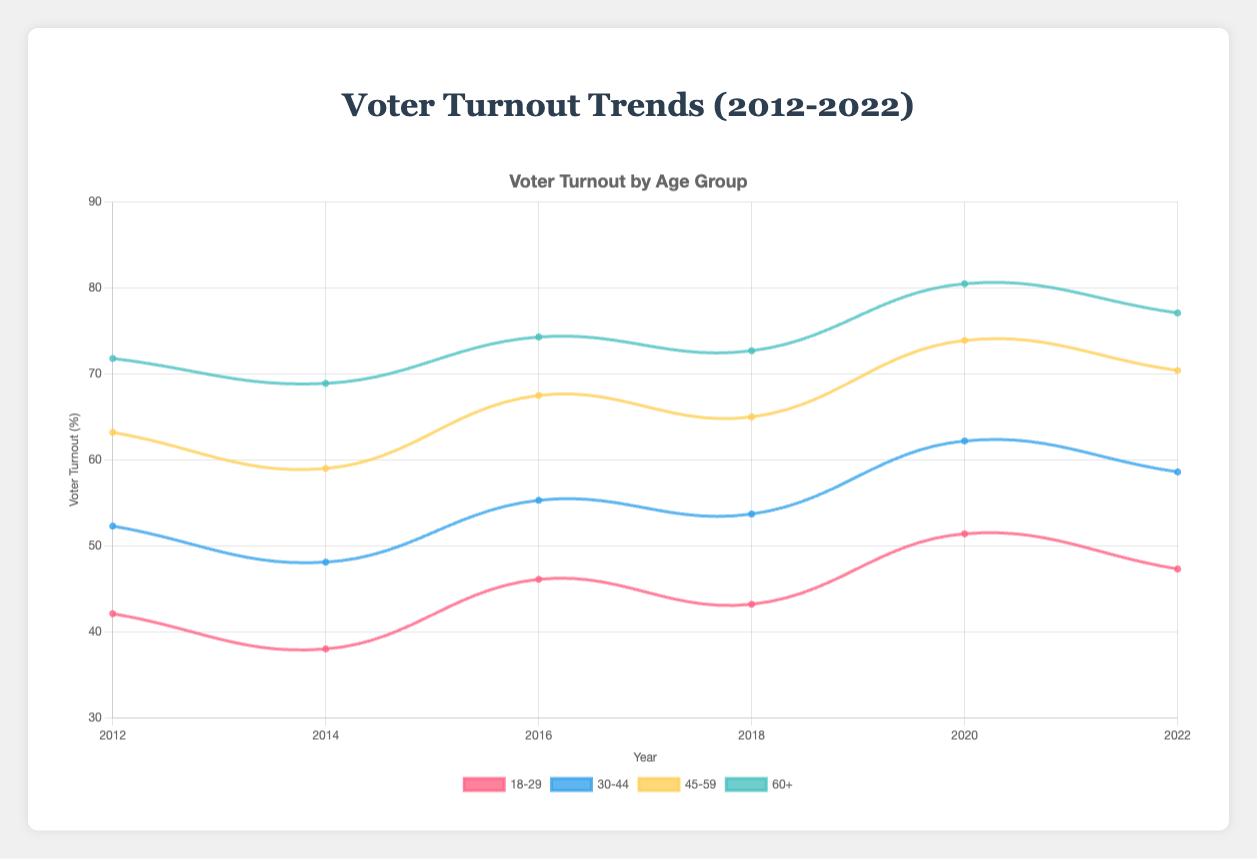What is the overall trend in voter turnout for the age group 18-29 from 2012 to 2022? From the figure, observe the pattern for the 18-29 age group data points. Start at 42.1% in 2012, dip to 38.0% in 2014, rise to 46.1% in 2016, 43.2% in 2018, peak at 51.4% in 2020, and slightly decrease to 47.3% in 2022. The general trend is a rise in turnout over the decade.
Answer: Rising Which age group had the highest voter turnout in 2020? Look at the data points for 2020 and compare the voter turnout across all age groups. For 2020, 60+ age group has 80.5%, which is higher than other age groups: 18-29 (51.4%), 30-44 (62.2%), and 45-59 (73.9%).
Answer: 60+ How did the voter turnout for the 30-44 age group change between 2012 and 2016? Compare the data points for 2012 and 2016 for the 30-44 age group. The turnout went from 52.3% in 2012 to 55.3% in 2016, which is an increase.
Answer: Increased What was the average voter turnout for the 60+ age group between 2014 and 2018? Add the values and divide by the number of data points: (68.9 + 74.3 + 72.7) / 3 = 216.9 / 3 = 72.3%.
Answer: 72.3% How did voter turnout for those with some college education change from 2018 to 2022? Compare the turnout for some college education in 2018 (59.9%) with 2022 (65.1%). It increased by (65.1 - 59.9) = 5.2 percentage points.
Answer: Increased by 5.2% 